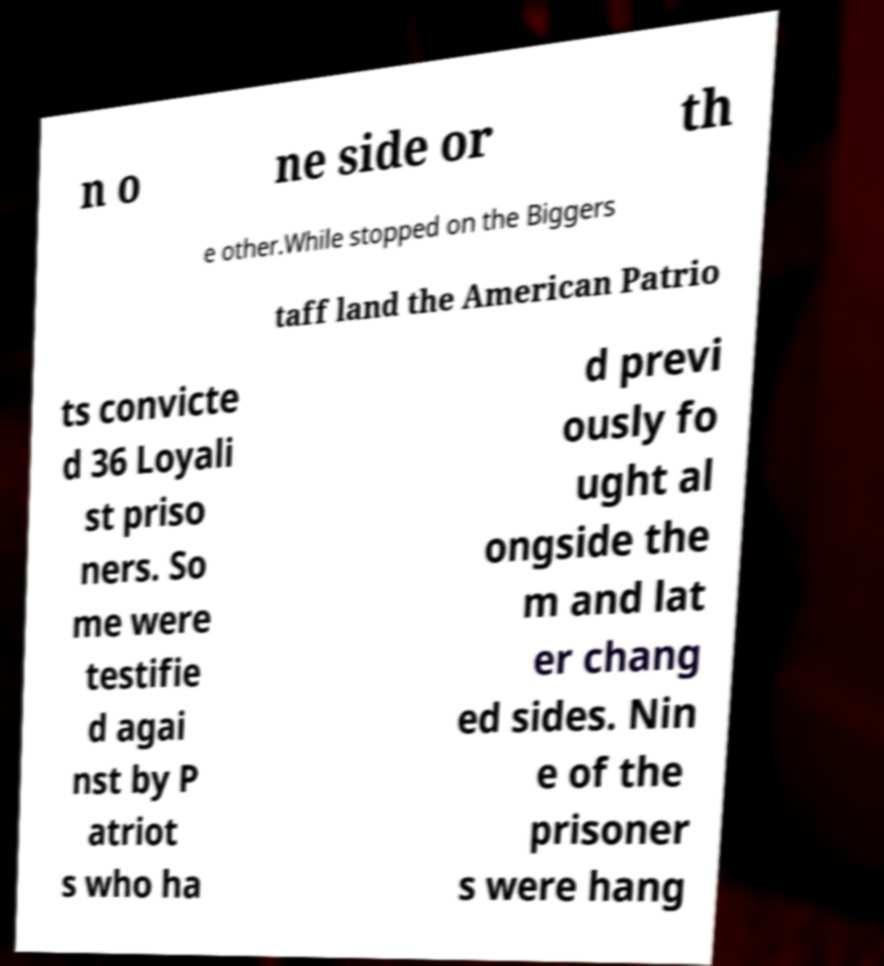Can you accurately transcribe the text from the provided image for me? n o ne side or th e other.While stopped on the Biggers taff land the American Patrio ts convicte d 36 Loyali st priso ners. So me were testifie d agai nst by P atriot s who ha d previ ously fo ught al ongside the m and lat er chang ed sides. Nin e of the prisoner s were hang 